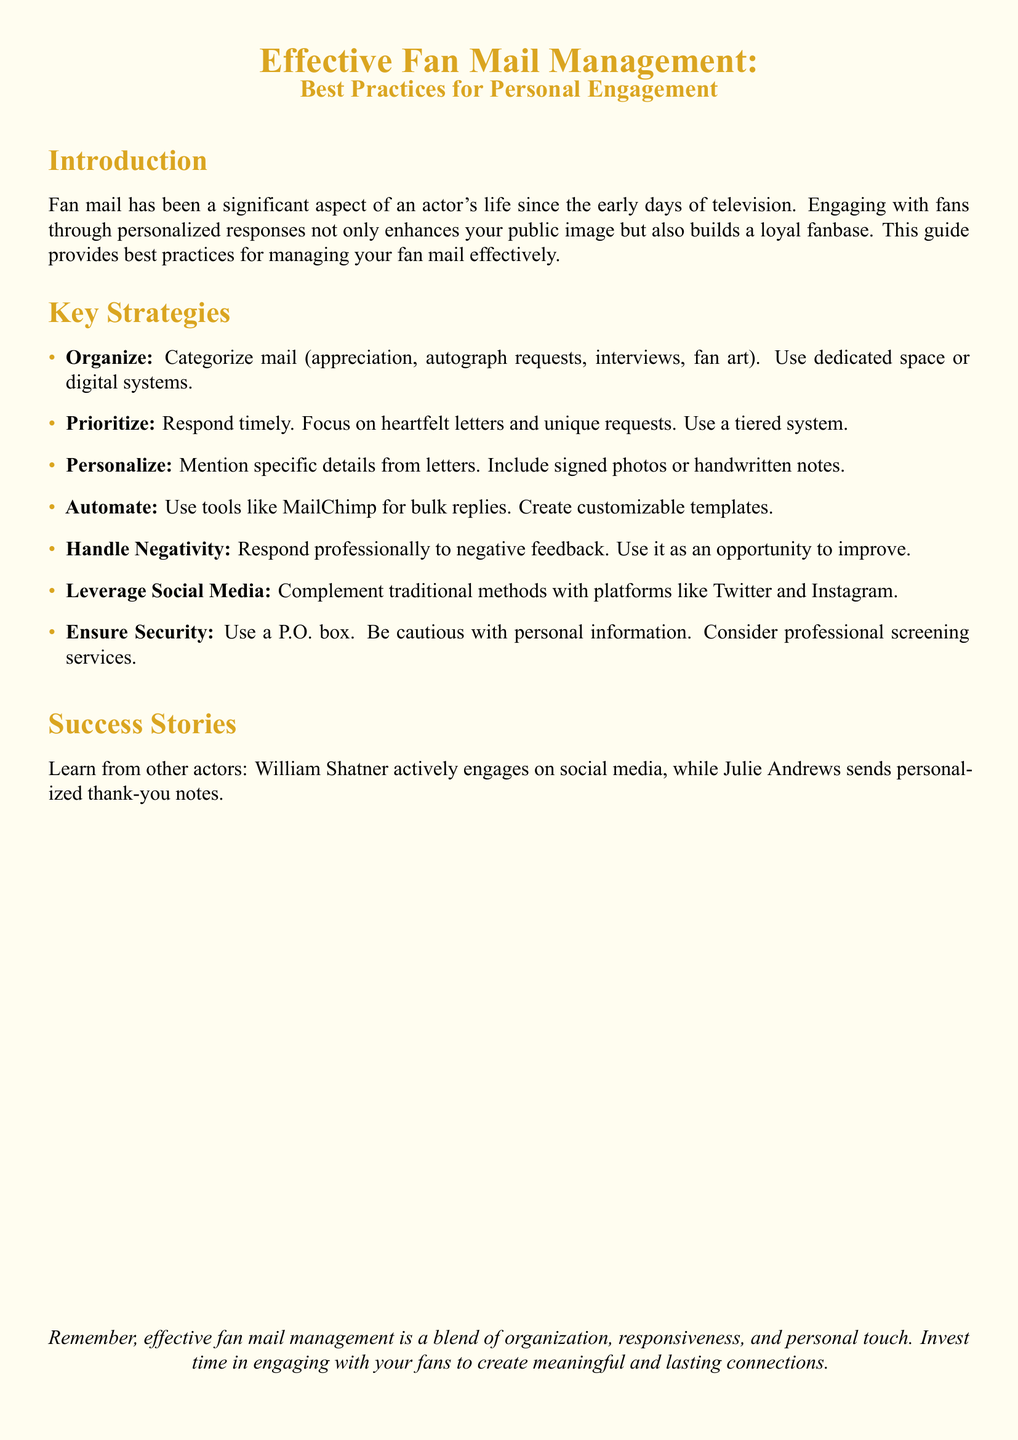What is the title of the document? The title is prominently displayed at the top, indicating the focus on fan mail management and engagement.
Answer: Effective Fan Mail Management: Best Practices for Personal Engagement What color is used for the bullet points? The document specifies a color for the bullet points, contributing to the overall aesthetic.
Answer: Gold How many key strategies are listed in the document? The number of strategies is reflected in the list provided under the Key Strategies section.
Answer: Seven What should you use to respond to negative feedback? The document advises on how to handle negativity in fan mail, highlighting a proactive approach.
Answer: Professionally Who is mentioned as engaging actively on social media? A specific actor is referenced to illustrate effective fan interaction via social media.
Answer: William Shatner What is recommended to ensure your security when managing fan mail? The guide provides tips on maintaining privacy and security in correspondence with fans.
Answer: Use a P.O. box What type of mail should be prioritized for responses? The guide emphasizes the importance of responding to certain types of letters for engagement.
Answer: Heartfelt letters 